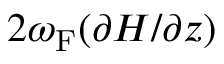<formula> <loc_0><loc_0><loc_500><loc_500>2 \omega _ { F } ( \partial H / \partial z )</formula> 